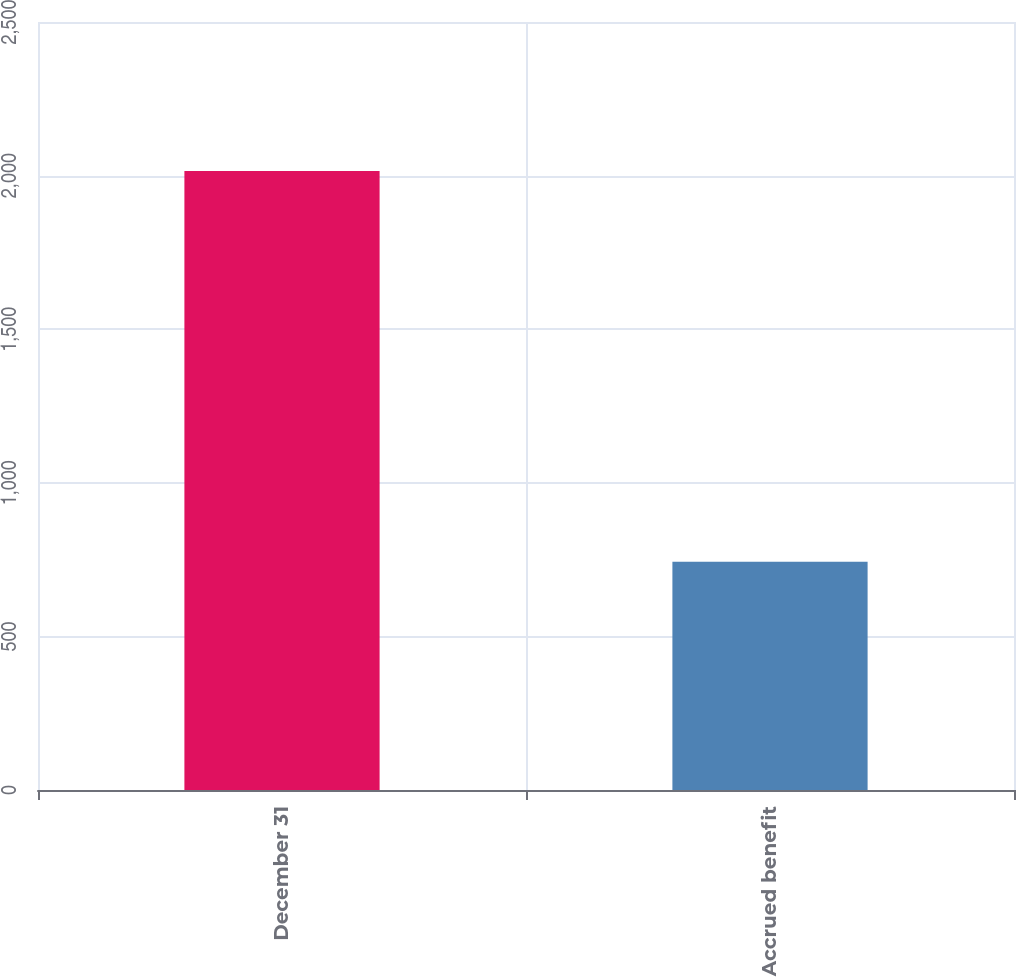Convert chart. <chart><loc_0><loc_0><loc_500><loc_500><bar_chart><fcel>December 31<fcel>Accrued benefit<nl><fcel>2015<fcel>743<nl></chart> 